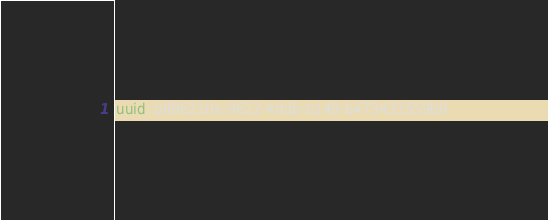<code> <loc_0><loc_0><loc_500><loc_500><_YAML_>uuid: b886210e-9622-4ddb-b149-b473431559b9</code> 